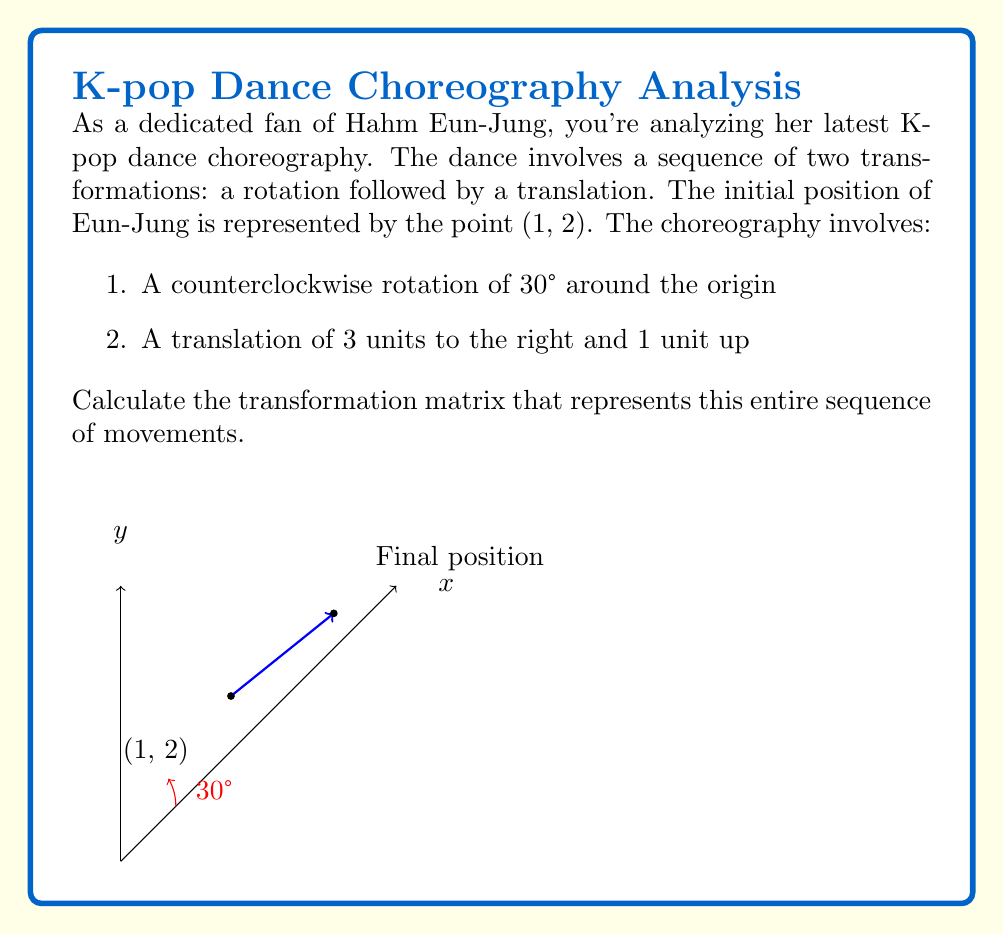Can you solve this math problem? Let's approach this step-by-step:

1) First, we need to recall the rotation matrix for a counterclockwise rotation by angle θ:

   $R_θ = \begin{pmatrix} \cos θ & -\sin θ \\ \sin θ & \cos θ \end{pmatrix}$

2) For our case, θ = 30°. Let's calculate the rotation matrix:

   $R_{30°} = \begin{pmatrix} \cos 30° & -\sin 30° \\ \sin 30° & \cos 30° \end{pmatrix} = \begin{pmatrix} \frac{\sqrt{3}}{2} & -\frac{1}{2} \\ \frac{1}{2} & \frac{\sqrt{3}}{2} \end{pmatrix}$

3) Next, we need to consider the translation. A translation by (tx, ty) can be represented in homogeneous coordinates as:

   $T = \begin{pmatrix} 1 & 0 & t_x \\ 0 & 1 & t_y \\ 0 & 0 & 1 \end{pmatrix}$

4) In our case, tx = 3 and ty = 1, so:

   $T = \begin{pmatrix} 1 & 0 & 3 \\ 0 & 1 & 1 \\ 0 & 0 & 1 \end{pmatrix}$

5) To combine these transformations, we need to multiply the matrices. The order matters: we rotate first, then translate. In matrix multiplication, this means the translation matrix goes on the left:

   $M = T \cdot R$

6) To perform this multiplication, we need to convert our rotation matrix to homogeneous coordinates:

   $R = \begin{pmatrix} \frac{\sqrt{3}}{2} & -\frac{1}{2} & 0 \\ \frac{1}{2} & \frac{\sqrt{3}}{2} & 0 \\ 0 & 0 & 1 \end{pmatrix}$

7) Now we can multiply:

   $M = \begin{pmatrix} 1 & 0 & 3 \\ 0 & 1 & 1 \\ 0 & 0 & 1 \end{pmatrix} \cdot \begin{pmatrix} \frac{\sqrt{3}}{2} & -\frac{1}{2} & 0 \\ \frac{1}{2} & \frac{\sqrt{3}}{2} & 0 \\ 0 & 0 & 1 \end{pmatrix}$

8) Performing the matrix multiplication:

   $M = \begin{pmatrix} \frac{\sqrt{3}}{2} & -\frac{1}{2} & 3 \\ \frac{1}{2} & \frac{\sqrt{3}}{2} & 1 \\ 0 & 0 & 1 \end{pmatrix}$

This final matrix M represents the entire sequence of transformations in Eun-Jung's choreography.
Answer: $$M = \begin{pmatrix} \frac{\sqrt{3}}{2} & -\frac{1}{2} & 3 \\ \frac{1}{2} & \frac{\sqrt{3}}{2} & 1 \\ 0 & 0 & 1 \end{pmatrix}$$ 